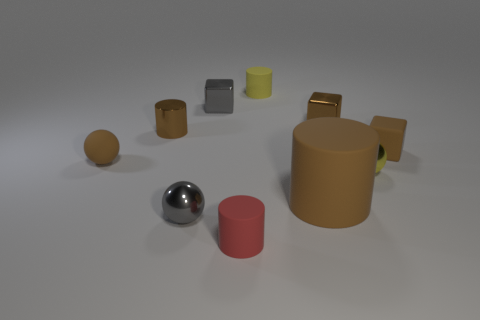Subtract all tiny yellow spheres. How many spheres are left? 2 Subtract all cubes. How many objects are left? 7 Subtract all tiny blue things. Subtract all tiny yellow shiny balls. How many objects are left? 9 Add 3 metal objects. How many metal objects are left? 8 Add 2 purple metallic blocks. How many purple metallic blocks exist? 2 Subtract all red cylinders. How many cylinders are left? 3 Subtract 0 cyan cylinders. How many objects are left? 10 Subtract 2 spheres. How many spheres are left? 1 Subtract all brown cylinders. Subtract all gray blocks. How many cylinders are left? 2 Subtract all purple spheres. How many brown cylinders are left? 2 